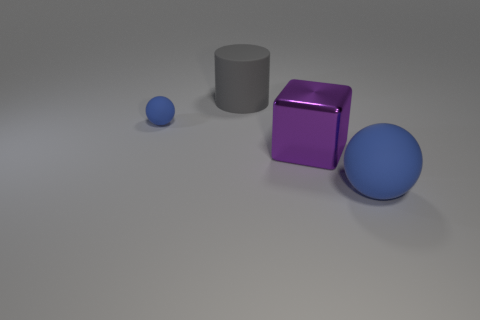Add 4 tiny brown cylinders. How many objects exist? 8 Subtract all cylinders. How many objects are left? 3 Subtract all green rubber blocks. Subtract all big gray cylinders. How many objects are left? 3 Add 1 tiny objects. How many tiny objects are left? 2 Add 1 large gray rubber cylinders. How many large gray rubber cylinders exist? 2 Subtract 0 red cubes. How many objects are left? 4 